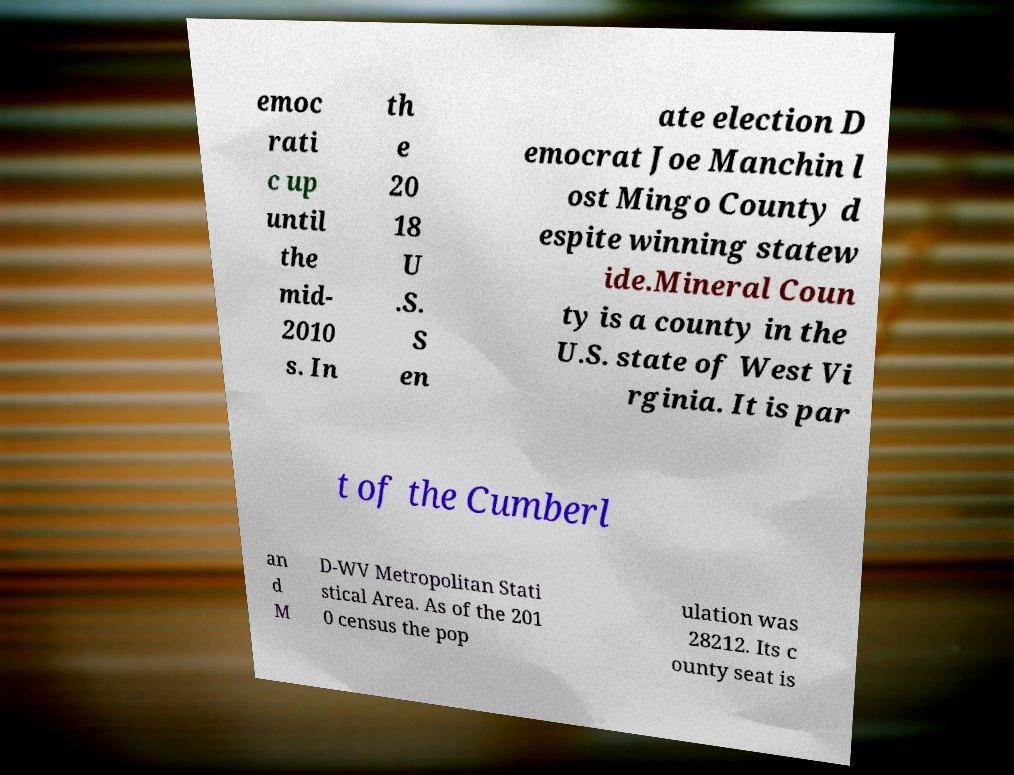Can you accurately transcribe the text from the provided image for me? emoc rati c up until the mid- 2010 s. In th e 20 18 U .S. S en ate election D emocrat Joe Manchin l ost Mingo County d espite winning statew ide.Mineral Coun ty is a county in the U.S. state of West Vi rginia. It is par t of the Cumberl an d M D-WV Metropolitan Stati stical Area. As of the 201 0 census the pop ulation was 28212. Its c ounty seat is 